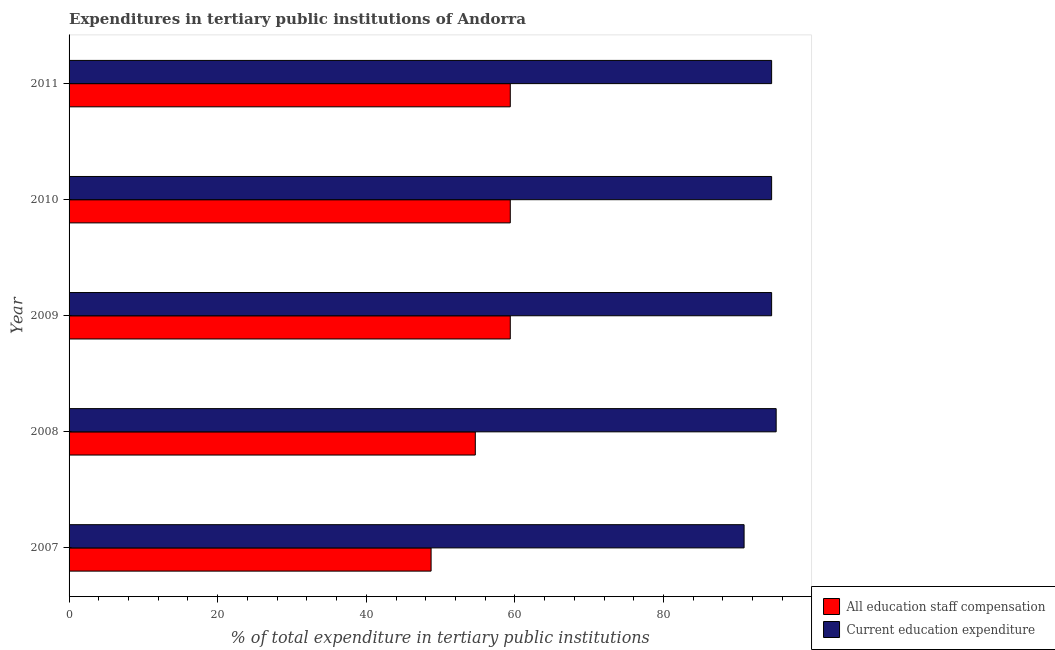How many different coloured bars are there?
Offer a very short reply. 2. How many groups of bars are there?
Your response must be concise. 5. Are the number of bars per tick equal to the number of legend labels?
Give a very brief answer. Yes. Are the number of bars on each tick of the Y-axis equal?
Provide a succinct answer. Yes. How many bars are there on the 1st tick from the top?
Your answer should be compact. 2. How many bars are there on the 3rd tick from the bottom?
Provide a succinct answer. 2. What is the label of the 3rd group of bars from the top?
Make the answer very short. 2009. What is the expenditure in staff compensation in 2007?
Offer a terse response. 48.72. Across all years, what is the maximum expenditure in education?
Ensure brevity in your answer.  95.16. Across all years, what is the minimum expenditure in staff compensation?
Ensure brevity in your answer.  48.72. What is the total expenditure in staff compensation in the graph?
Provide a succinct answer. 281.53. What is the difference between the expenditure in staff compensation in 2007 and that in 2008?
Your response must be concise. -5.95. What is the difference between the expenditure in staff compensation in 2011 and the expenditure in education in 2010?
Ensure brevity in your answer.  -35.17. What is the average expenditure in education per year?
Offer a terse response. 93.93. In the year 2009, what is the difference between the expenditure in education and expenditure in staff compensation?
Make the answer very short. 35.17. In how many years, is the expenditure in staff compensation greater than 92 %?
Ensure brevity in your answer.  0. What is the ratio of the expenditure in staff compensation in 2008 to that in 2009?
Your response must be concise. 0.92. What is the difference between the highest and the second highest expenditure in staff compensation?
Provide a short and direct response. 0. What is the difference between the highest and the lowest expenditure in staff compensation?
Make the answer very short. 10.66. Is the sum of the expenditure in education in 2009 and 2010 greater than the maximum expenditure in staff compensation across all years?
Offer a terse response. Yes. What does the 1st bar from the top in 2010 represents?
Provide a short and direct response. Current education expenditure. What does the 1st bar from the bottom in 2009 represents?
Provide a short and direct response. All education staff compensation. How many bars are there?
Your answer should be compact. 10. Are all the bars in the graph horizontal?
Offer a very short reply. Yes. What is the difference between two consecutive major ticks on the X-axis?
Offer a terse response. 20. Are the values on the major ticks of X-axis written in scientific E-notation?
Offer a very short reply. No. Does the graph contain grids?
Provide a short and direct response. No. Where does the legend appear in the graph?
Make the answer very short. Bottom right. What is the title of the graph?
Your response must be concise. Expenditures in tertiary public institutions of Andorra. Does "Gasoline" appear as one of the legend labels in the graph?
Make the answer very short. No. What is the label or title of the X-axis?
Your answer should be very brief. % of total expenditure in tertiary public institutions. What is the % of total expenditure in tertiary public institutions in All education staff compensation in 2007?
Provide a short and direct response. 48.72. What is the % of total expenditure in tertiary public institutions in Current education expenditure in 2007?
Provide a short and direct response. 90.84. What is the % of total expenditure in tertiary public institutions of All education staff compensation in 2008?
Make the answer very short. 54.67. What is the % of total expenditure in tertiary public institutions of Current education expenditure in 2008?
Provide a succinct answer. 95.16. What is the % of total expenditure in tertiary public institutions in All education staff compensation in 2009?
Make the answer very short. 59.38. What is the % of total expenditure in tertiary public institutions of Current education expenditure in 2009?
Provide a short and direct response. 94.55. What is the % of total expenditure in tertiary public institutions in All education staff compensation in 2010?
Offer a terse response. 59.38. What is the % of total expenditure in tertiary public institutions of Current education expenditure in 2010?
Your response must be concise. 94.55. What is the % of total expenditure in tertiary public institutions of All education staff compensation in 2011?
Offer a very short reply. 59.38. What is the % of total expenditure in tertiary public institutions of Current education expenditure in 2011?
Make the answer very short. 94.55. Across all years, what is the maximum % of total expenditure in tertiary public institutions of All education staff compensation?
Give a very brief answer. 59.38. Across all years, what is the maximum % of total expenditure in tertiary public institutions in Current education expenditure?
Your answer should be compact. 95.16. Across all years, what is the minimum % of total expenditure in tertiary public institutions of All education staff compensation?
Your answer should be compact. 48.72. Across all years, what is the minimum % of total expenditure in tertiary public institutions of Current education expenditure?
Offer a very short reply. 90.84. What is the total % of total expenditure in tertiary public institutions in All education staff compensation in the graph?
Offer a terse response. 281.53. What is the total % of total expenditure in tertiary public institutions in Current education expenditure in the graph?
Your answer should be compact. 469.66. What is the difference between the % of total expenditure in tertiary public institutions in All education staff compensation in 2007 and that in 2008?
Your response must be concise. -5.95. What is the difference between the % of total expenditure in tertiary public institutions of Current education expenditure in 2007 and that in 2008?
Keep it short and to the point. -4.32. What is the difference between the % of total expenditure in tertiary public institutions in All education staff compensation in 2007 and that in 2009?
Keep it short and to the point. -10.66. What is the difference between the % of total expenditure in tertiary public institutions of Current education expenditure in 2007 and that in 2009?
Ensure brevity in your answer.  -3.71. What is the difference between the % of total expenditure in tertiary public institutions in All education staff compensation in 2007 and that in 2010?
Your answer should be compact. -10.66. What is the difference between the % of total expenditure in tertiary public institutions of Current education expenditure in 2007 and that in 2010?
Ensure brevity in your answer.  -3.71. What is the difference between the % of total expenditure in tertiary public institutions in All education staff compensation in 2007 and that in 2011?
Provide a succinct answer. -10.66. What is the difference between the % of total expenditure in tertiary public institutions of Current education expenditure in 2007 and that in 2011?
Offer a terse response. -3.71. What is the difference between the % of total expenditure in tertiary public institutions in All education staff compensation in 2008 and that in 2009?
Your answer should be very brief. -4.71. What is the difference between the % of total expenditure in tertiary public institutions in Current education expenditure in 2008 and that in 2009?
Provide a short and direct response. 0.61. What is the difference between the % of total expenditure in tertiary public institutions of All education staff compensation in 2008 and that in 2010?
Your response must be concise. -4.71. What is the difference between the % of total expenditure in tertiary public institutions in Current education expenditure in 2008 and that in 2010?
Ensure brevity in your answer.  0.61. What is the difference between the % of total expenditure in tertiary public institutions in All education staff compensation in 2008 and that in 2011?
Give a very brief answer. -4.71. What is the difference between the % of total expenditure in tertiary public institutions of Current education expenditure in 2008 and that in 2011?
Keep it short and to the point. 0.61. What is the difference between the % of total expenditure in tertiary public institutions of All education staff compensation in 2010 and that in 2011?
Make the answer very short. 0. What is the difference between the % of total expenditure in tertiary public institutions in Current education expenditure in 2010 and that in 2011?
Your response must be concise. 0. What is the difference between the % of total expenditure in tertiary public institutions of All education staff compensation in 2007 and the % of total expenditure in tertiary public institutions of Current education expenditure in 2008?
Keep it short and to the point. -46.44. What is the difference between the % of total expenditure in tertiary public institutions of All education staff compensation in 2007 and the % of total expenditure in tertiary public institutions of Current education expenditure in 2009?
Ensure brevity in your answer.  -45.83. What is the difference between the % of total expenditure in tertiary public institutions of All education staff compensation in 2007 and the % of total expenditure in tertiary public institutions of Current education expenditure in 2010?
Your response must be concise. -45.83. What is the difference between the % of total expenditure in tertiary public institutions of All education staff compensation in 2007 and the % of total expenditure in tertiary public institutions of Current education expenditure in 2011?
Ensure brevity in your answer.  -45.83. What is the difference between the % of total expenditure in tertiary public institutions of All education staff compensation in 2008 and the % of total expenditure in tertiary public institutions of Current education expenditure in 2009?
Your answer should be compact. -39.88. What is the difference between the % of total expenditure in tertiary public institutions of All education staff compensation in 2008 and the % of total expenditure in tertiary public institutions of Current education expenditure in 2010?
Provide a short and direct response. -39.88. What is the difference between the % of total expenditure in tertiary public institutions in All education staff compensation in 2008 and the % of total expenditure in tertiary public institutions in Current education expenditure in 2011?
Provide a succinct answer. -39.88. What is the difference between the % of total expenditure in tertiary public institutions of All education staff compensation in 2009 and the % of total expenditure in tertiary public institutions of Current education expenditure in 2010?
Provide a succinct answer. -35.17. What is the difference between the % of total expenditure in tertiary public institutions in All education staff compensation in 2009 and the % of total expenditure in tertiary public institutions in Current education expenditure in 2011?
Your response must be concise. -35.17. What is the difference between the % of total expenditure in tertiary public institutions in All education staff compensation in 2010 and the % of total expenditure in tertiary public institutions in Current education expenditure in 2011?
Give a very brief answer. -35.17. What is the average % of total expenditure in tertiary public institutions of All education staff compensation per year?
Give a very brief answer. 56.31. What is the average % of total expenditure in tertiary public institutions in Current education expenditure per year?
Make the answer very short. 93.93. In the year 2007, what is the difference between the % of total expenditure in tertiary public institutions of All education staff compensation and % of total expenditure in tertiary public institutions of Current education expenditure?
Give a very brief answer. -42.12. In the year 2008, what is the difference between the % of total expenditure in tertiary public institutions in All education staff compensation and % of total expenditure in tertiary public institutions in Current education expenditure?
Provide a succinct answer. -40.49. In the year 2009, what is the difference between the % of total expenditure in tertiary public institutions of All education staff compensation and % of total expenditure in tertiary public institutions of Current education expenditure?
Your answer should be compact. -35.17. In the year 2010, what is the difference between the % of total expenditure in tertiary public institutions of All education staff compensation and % of total expenditure in tertiary public institutions of Current education expenditure?
Offer a terse response. -35.17. In the year 2011, what is the difference between the % of total expenditure in tertiary public institutions of All education staff compensation and % of total expenditure in tertiary public institutions of Current education expenditure?
Offer a terse response. -35.17. What is the ratio of the % of total expenditure in tertiary public institutions in All education staff compensation in 2007 to that in 2008?
Your answer should be very brief. 0.89. What is the ratio of the % of total expenditure in tertiary public institutions in Current education expenditure in 2007 to that in 2008?
Provide a short and direct response. 0.95. What is the ratio of the % of total expenditure in tertiary public institutions of All education staff compensation in 2007 to that in 2009?
Offer a very short reply. 0.82. What is the ratio of the % of total expenditure in tertiary public institutions in Current education expenditure in 2007 to that in 2009?
Your answer should be very brief. 0.96. What is the ratio of the % of total expenditure in tertiary public institutions of All education staff compensation in 2007 to that in 2010?
Ensure brevity in your answer.  0.82. What is the ratio of the % of total expenditure in tertiary public institutions in Current education expenditure in 2007 to that in 2010?
Offer a very short reply. 0.96. What is the ratio of the % of total expenditure in tertiary public institutions of All education staff compensation in 2007 to that in 2011?
Offer a very short reply. 0.82. What is the ratio of the % of total expenditure in tertiary public institutions of Current education expenditure in 2007 to that in 2011?
Your answer should be compact. 0.96. What is the ratio of the % of total expenditure in tertiary public institutions in All education staff compensation in 2008 to that in 2009?
Your answer should be compact. 0.92. What is the ratio of the % of total expenditure in tertiary public institutions of All education staff compensation in 2008 to that in 2010?
Keep it short and to the point. 0.92. What is the ratio of the % of total expenditure in tertiary public institutions of Current education expenditure in 2008 to that in 2010?
Provide a succinct answer. 1.01. What is the ratio of the % of total expenditure in tertiary public institutions of All education staff compensation in 2008 to that in 2011?
Keep it short and to the point. 0.92. What is the ratio of the % of total expenditure in tertiary public institutions in Current education expenditure in 2009 to that in 2011?
Make the answer very short. 1. What is the ratio of the % of total expenditure in tertiary public institutions of All education staff compensation in 2010 to that in 2011?
Make the answer very short. 1. What is the difference between the highest and the second highest % of total expenditure in tertiary public institutions of Current education expenditure?
Provide a succinct answer. 0.61. What is the difference between the highest and the lowest % of total expenditure in tertiary public institutions in All education staff compensation?
Ensure brevity in your answer.  10.66. What is the difference between the highest and the lowest % of total expenditure in tertiary public institutions of Current education expenditure?
Offer a terse response. 4.32. 